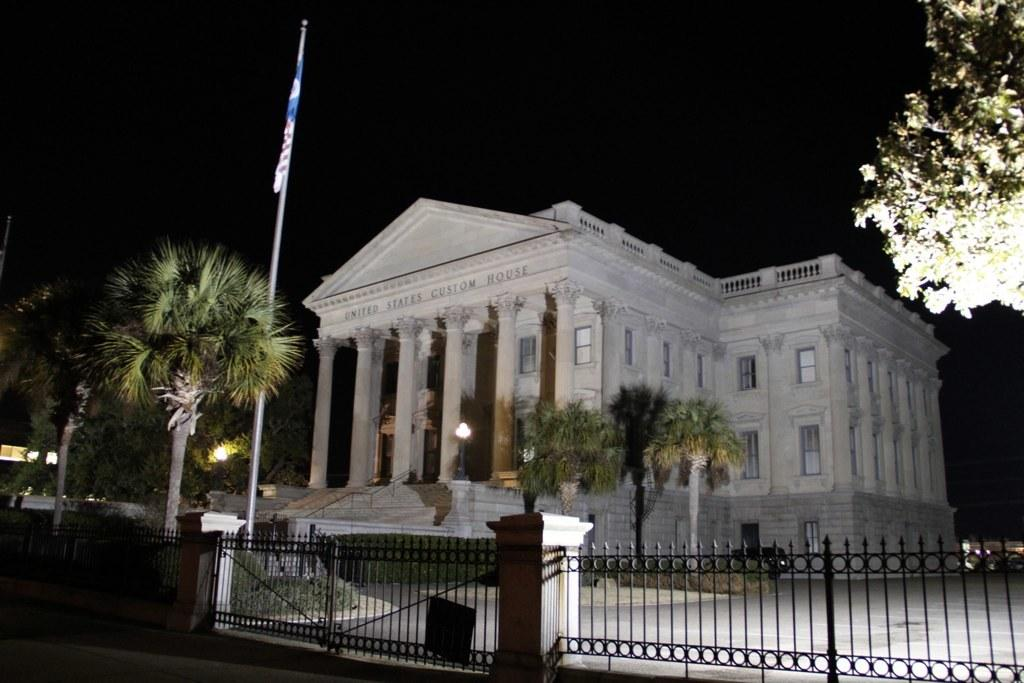What is the color of the building in the image? The building in the image is white. What type of vegetation can be seen in the image? There are trees in the image. What is flying in the image? There is a flag in the image. What type of barrier is present in the image? There is a fence in the image. What can be seen in the background of the image? The sky is visible in the background of the image. What type of mine is visible in the image? There is no mine present in the image. What color is the mitten on the fence in the image? There is no mitten present in the image. 